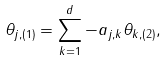<formula> <loc_0><loc_0><loc_500><loc_500>\theta _ { j , ( 1 ) } = \sum _ { k = 1 } ^ { d } - a _ { j , k } \theta _ { k , ( 2 ) } ,</formula> 